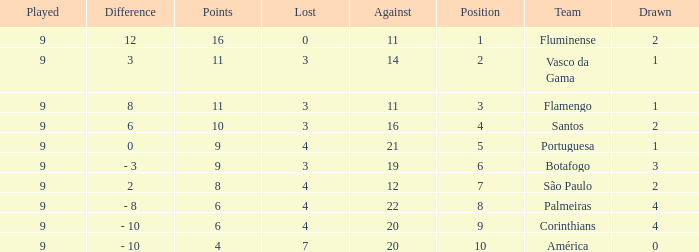Which Lost is the highest one that has a Drawn smaller than 4, and a Played smaller than 9? None. 